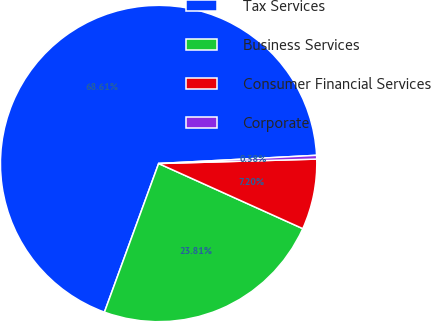<chart> <loc_0><loc_0><loc_500><loc_500><pie_chart><fcel>Tax Services<fcel>Business Services<fcel>Consumer Financial Services<fcel>Corporate<nl><fcel>68.6%<fcel>23.81%<fcel>7.2%<fcel>0.38%<nl></chart> 